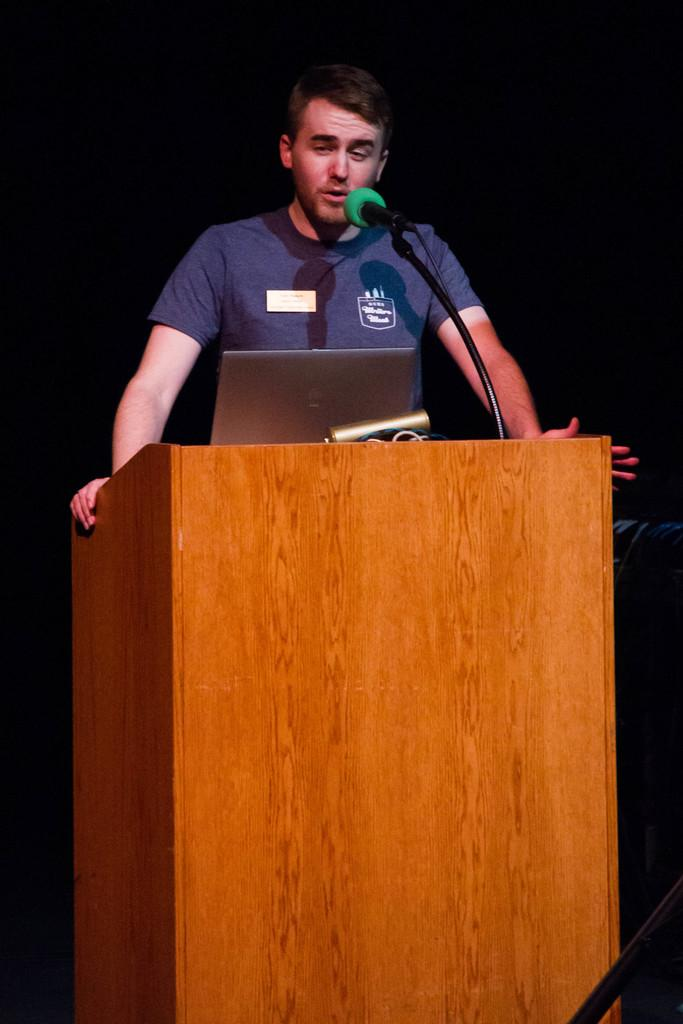Who is the main subject in the image? There is a man in the image. What is the man doing in the image? The man is standing behind a podium. What items are on the podium with the man? There is a laptop and a microphone on the podium. What can be inferred about the lighting in the image? The background of the image is dark. What type of ornament is hanging from the man's neck in the image? There is no ornament hanging from the man's neck in the image. How much payment is the man receiving for his speech in the image? There is no information about payment in the image. 